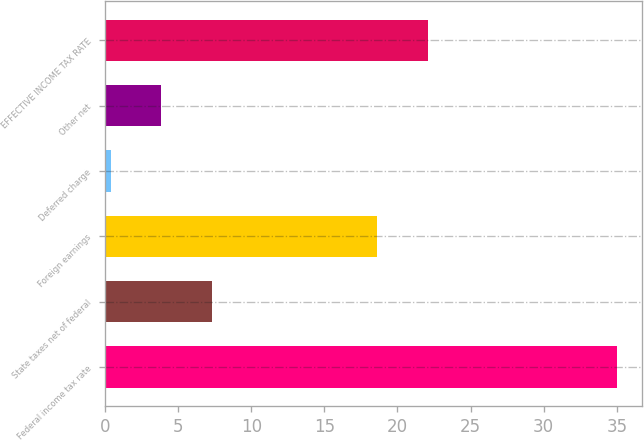Convert chart to OTSL. <chart><loc_0><loc_0><loc_500><loc_500><bar_chart><fcel>Federal income tax rate<fcel>State taxes net of federal<fcel>Foreign earnings<fcel>Deferred charge<fcel>Other net<fcel>EFFECTIVE INCOME TAX RATE<nl><fcel>35<fcel>7.32<fcel>18.6<fcel>0.4<fcel>3.86<fcel>22.06<nl></chart> 